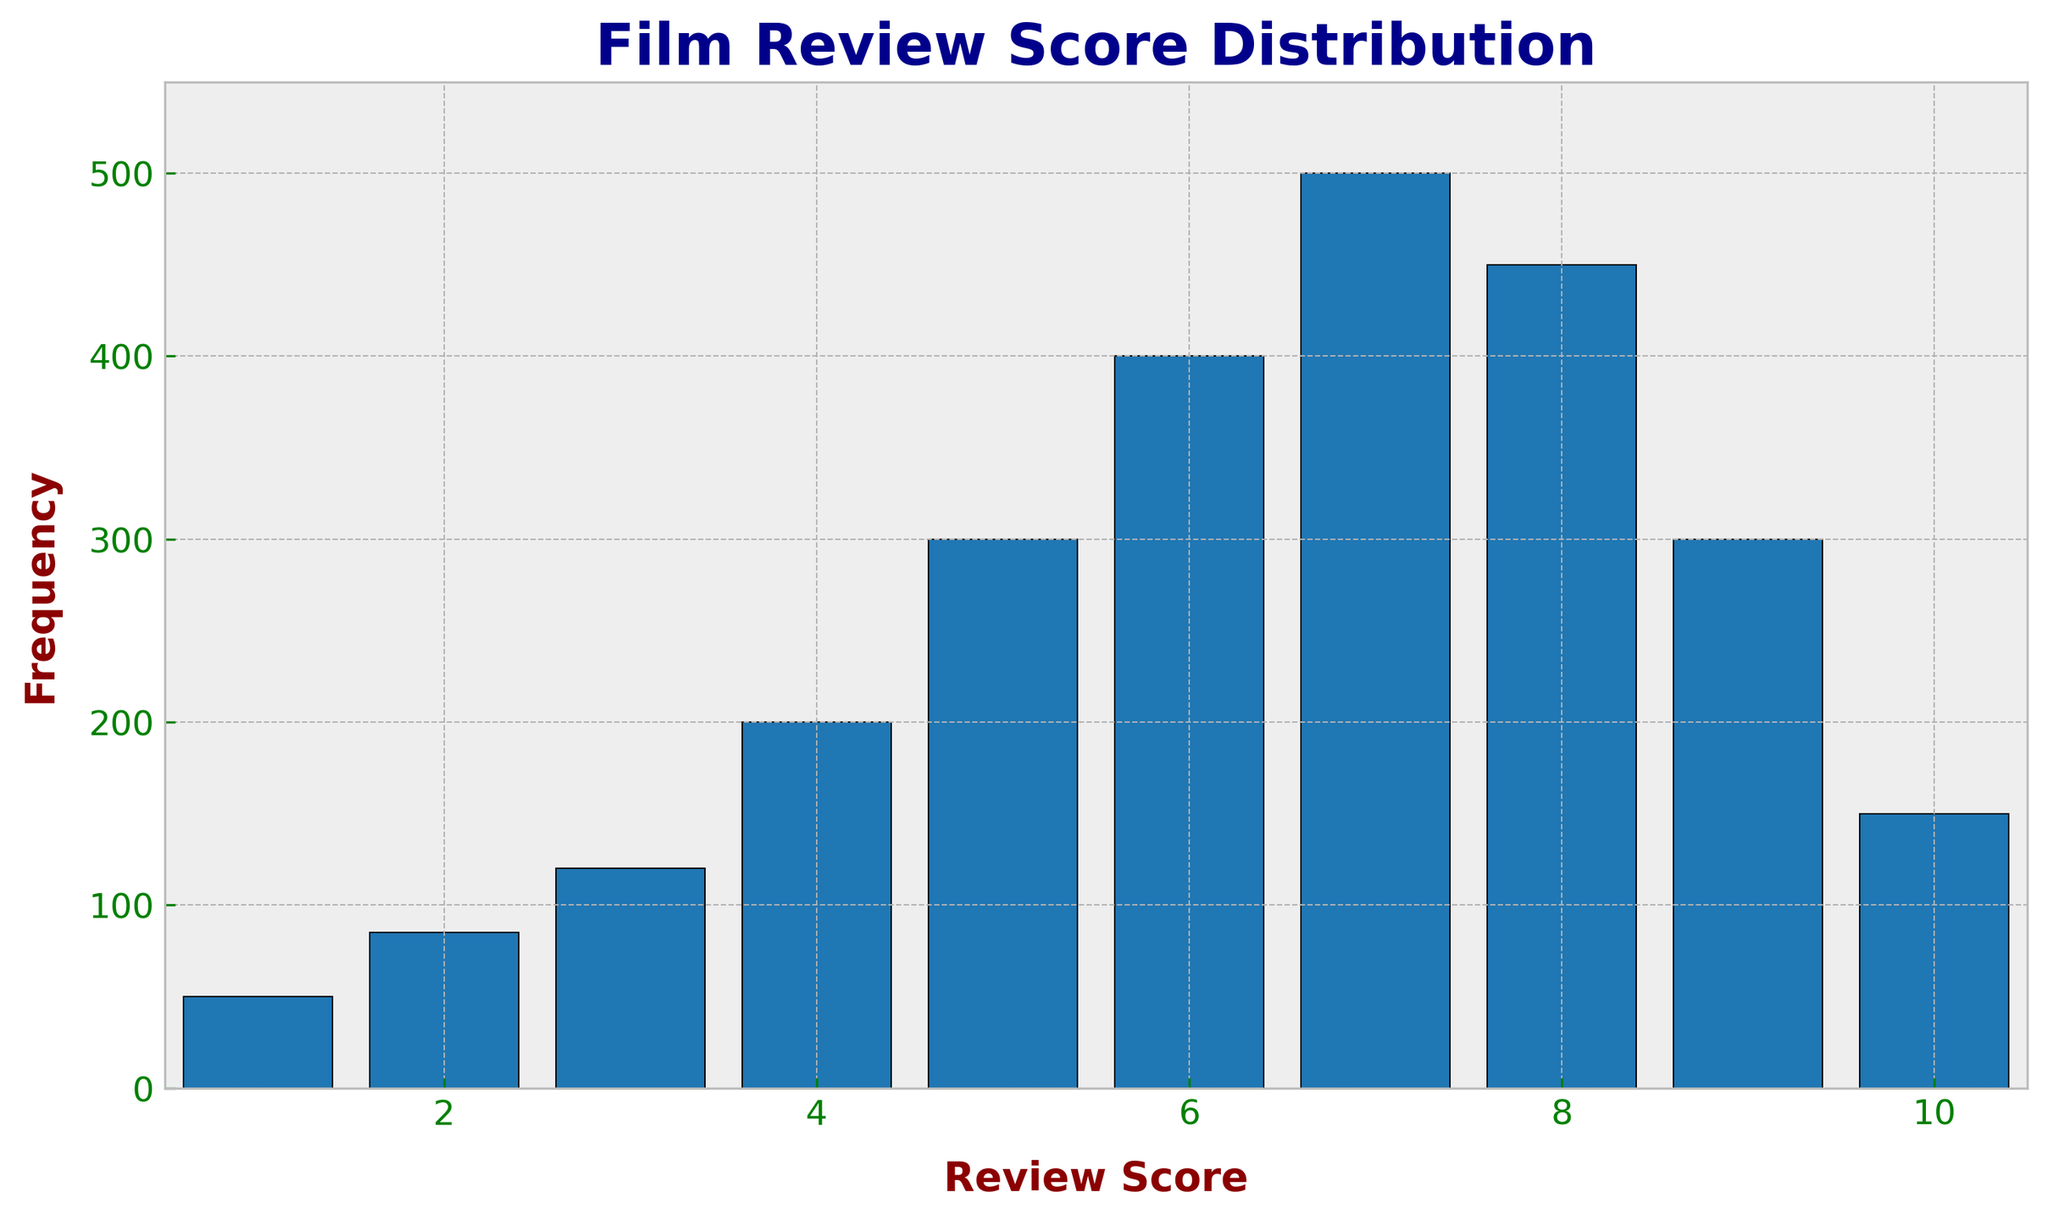What's the most frequent review score? The highest bar in the histogram represents the most frequent review score, which is the score corresponding to the tallest bar. The score of 7 has the highest frequency of 500.
Answer: 7 What's the least frequent review score? The smallest bar in the histogram represents the least frequent review score. The score of 1 has the lowest frequency of 50.
Answer: 1 What is the total number of reviews for scores greater than 7? Add the frequencies of all scores greater than 7. Scores 8, 9, and 10 have frequencies 450, 300, and 150, respectively. So, 450 + 300 + 150 = 900.
Answer: 900 How many reviews fall in the middle range between scores 4 and 6 inclusive? Add the frequencies of the scores 4, 5, and 6. The frequencies are 200, 300, and 400, respectively. So, 200 + 300 + 400 = 900.
Answer: 900 By how much does the frequency of score 7 exceed the frequency of score 8? Subtract the frequency of score 8 from the frequency of score 7. The frequencies are 500 and 450, respectively. So, 500 - 450 = 50.
Answer: 50 Which review score has the frequency exactly equal to the average frequency of the scores 1 and 10? First, find the average frequency of scores 1 and 10. It's (50 + 150) / 2 = 100. The review score with frequency 100 does not exist; the closest frequencies are 85 and 120 for scores 2 and 3, respectively. So none match exactly.
Answer: None Which scores have taller bars, 3 or 9? Compare the heights of the bars for scores 3 and 9. Score 3 has a frequency of 120, while score 9 has a frequency of 300. So, score 9 has a taller bar.
Answer: 9 What's the range of frequencies in the histogram? Find the difference between the maximum frequency and the minimum frequency. The maximum frequency is 500 (score 7) and the minimum is 50 (score 1), so the range is 500 - 50 = 450.
Answer: 450 What is the total number of reviews observed in the histogram? Sum all the frequencies of the scores. 50 + 85 + 120 + 200 + 300 + 400 + 500 + 450 + 300 + 150 = 2555.
Answer: 2555 